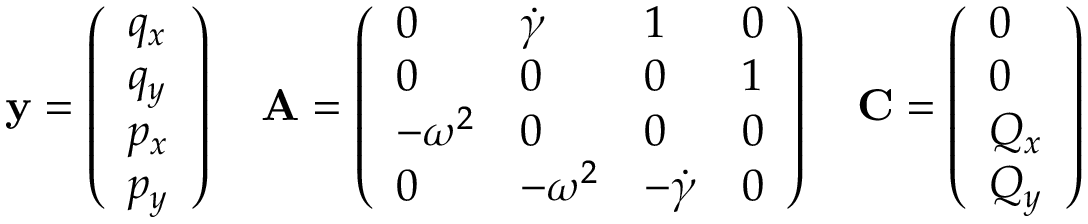Convert formula to latex. <formula><loc_0><loc_0><loc_500><loc_500>{ y } = \left ( \begin{array} { l } { q _ { x } } \\ { q _ { y } } \\ { p _ { x } } \\ { p _ { y } } \end{array} \right ) \quad A = \left ( \begin{array} { l l l l } { 0 } & { \dot { \gamma } } & { 1 } & { 0 } \\ { 0 } & { 0 } & { 0 } & { 1 } \\ { - \omega ^ { 2 } } & { 0 } & { 0 } & { 0 } \\ { 0 } & { - \omega ^ { 2 } } & { - \dot { \gamma } } & { 0 } \end{array} \right ) \quad C = \left ( \begin{array} { l } { 0 } \\ { 0 } \\ { Q _ { x } } \\ { Q _ { y } } \end{array} \right )</formula> 